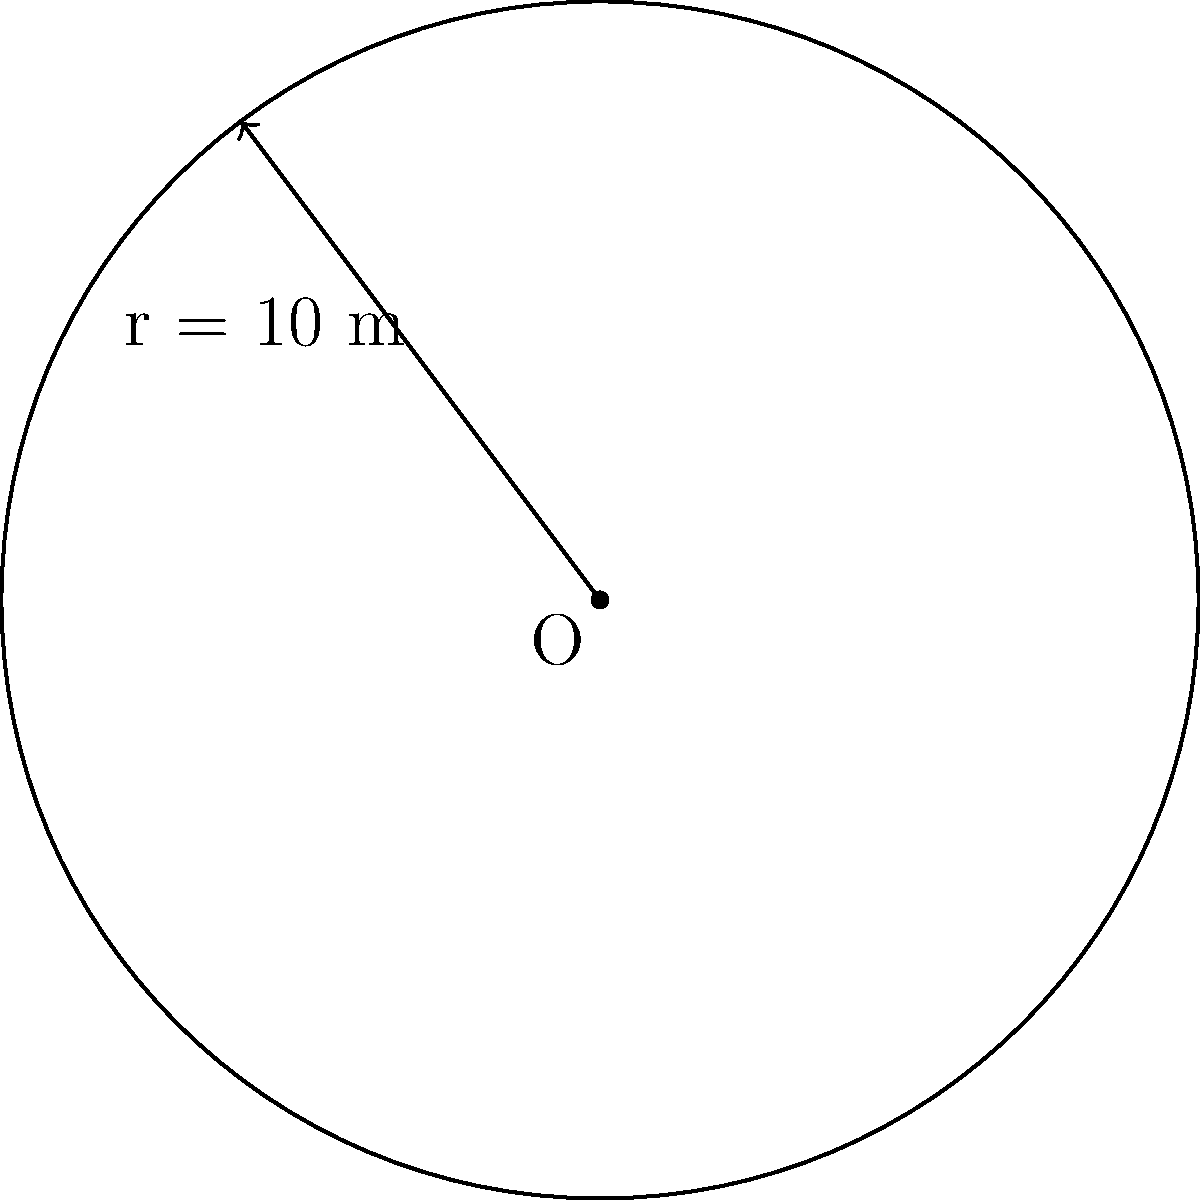As a music industry veteran, you're planning a massive pop concert featuring the next big star. The circular stage needs to be large enough to accommodate the performer and their dancers. If the radius of the stage is 10 meters, what is the total area of the stage in square meters? Round your answer to the nearest whole number. To find the area of a circular stage, we need to use the formula for the area of a circle:

$$A = \pi r^2$$

Where:
$A$ = area of the circle
$\pi$ (pi) ≈ 3.14159
$r$ = radius of the circle

Given:
radius ($r$) = 10 meters

Let's calculate:

1) Substitute the values into the formula:
   $$A = \pi \times 10^2$$

2) Calculate the square of the radius:
   $$A = \pi \times 100$$

3) Multiply by pi:
   $$A = 3.14159 \times 100 = 314.159$$

4) Round to the nearest whole number:
   $$A \approx 314 \text{ m}^2$$

Therefore, the total area of the circular stage is approximately 314 square meters.
Answer: 314 m² 